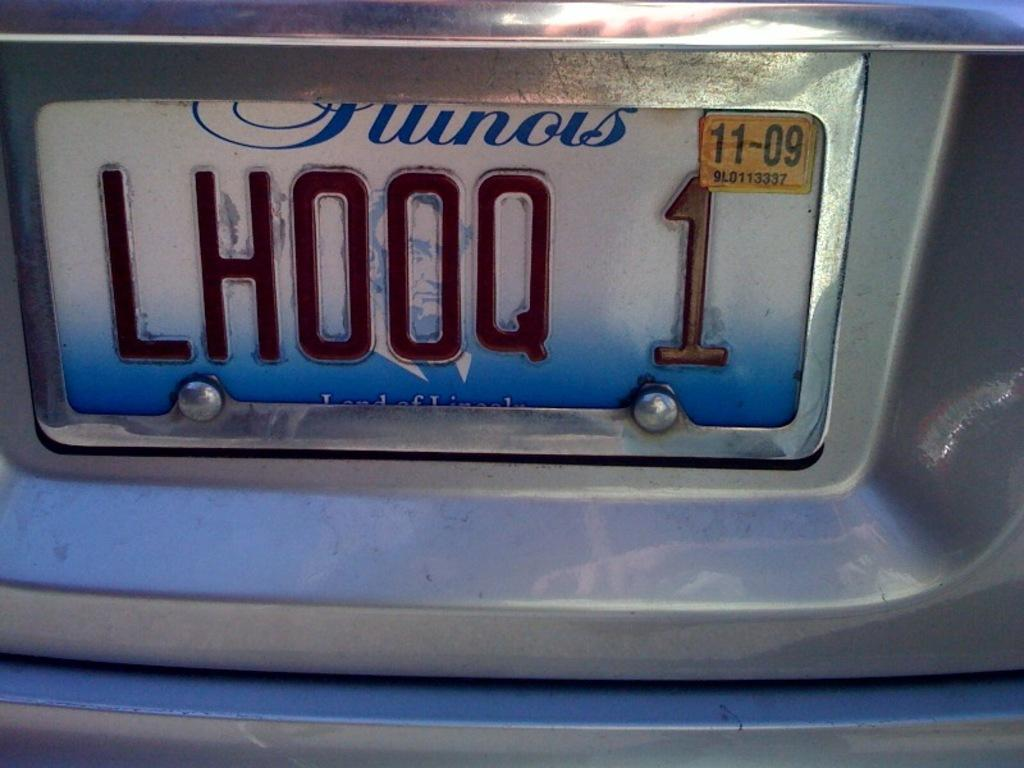<image>
Give a short and clear explanation of the subsequent image. A license plate with a yellow registraion sticker with expiration date 11-09 